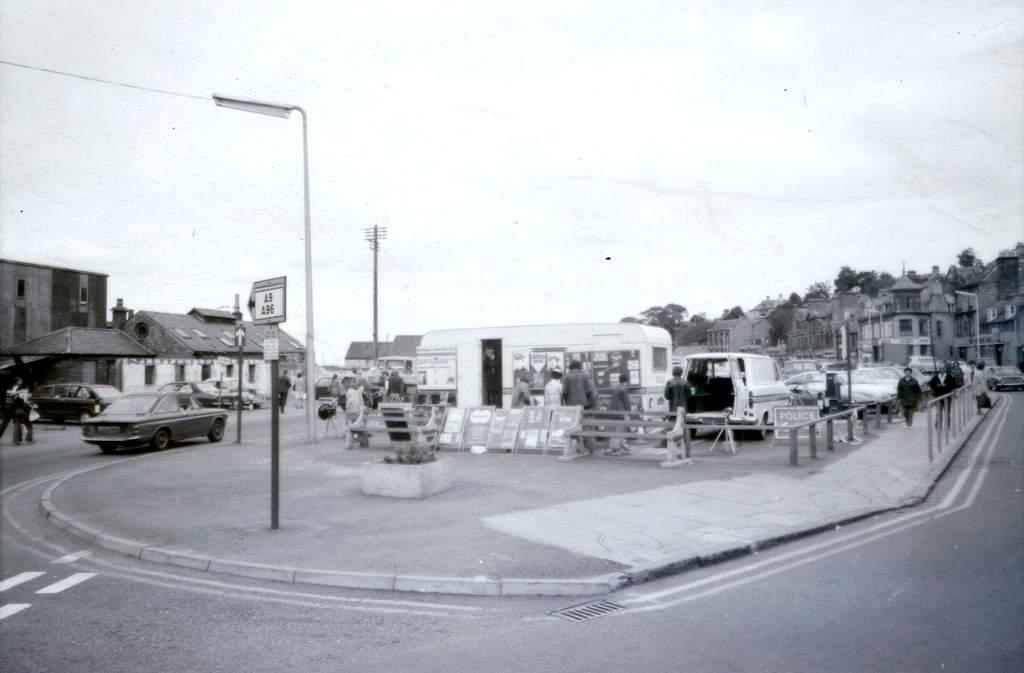What is the color scheme of the image? The image is black and white. What can be seen in the center of the image? There is a sky in the center of the image. What type of structures are visible in the image? There are buildings in the image. What type of vegetation is present in the image? Trees are present in the image. What type of transportation is visible in the image? Vehicles are visible in the image. What type of vertical structures are in the image? Poles are in the image. What type of informational signs are present in the image? Sign boards are present in the image. Are there any living beings visible in the image? Yes, there are people in the image. What other objects can be seen in the image? There are other objects in the image. What type of grain is being harvested by the pets in the image? There are no pets or grain present in the image. What impulse caused the people to gather in the image? The image does not provide information about the reason or impulse for the people to gather. 